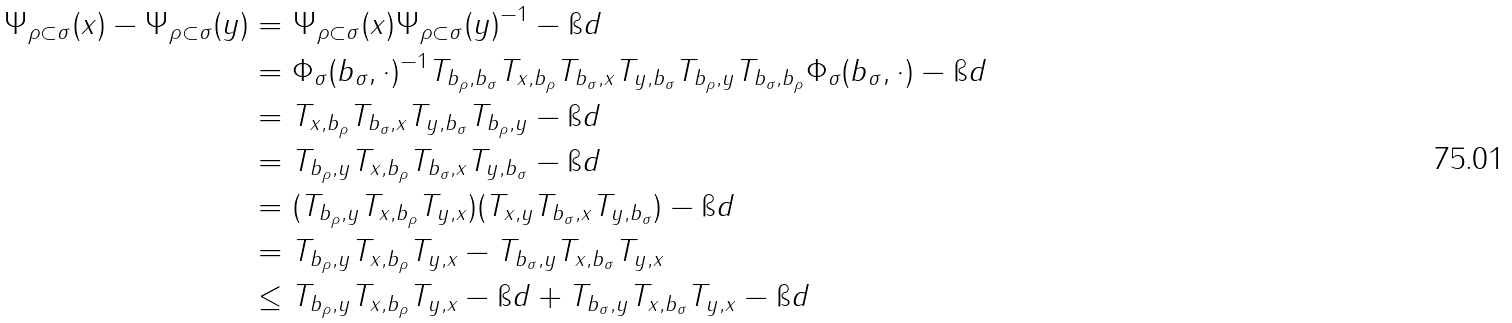<formula> <loc_0><loc_0><loc_500><loc_500>\| \Psi _ { \rho \subset \sigma } ( x ) - \Psi _ { \rho \subset \sigma } ( y ) \| & = \| \Psi _ { \rho \subset \sigma } ( x ) \Psi _ { \rho \subset \sigma } ( y ) ^ { - 1 } - \i d \| \\ & = \| \Phi _ { \sigma } ( b _ { \sigma } , \cdot ) ^ { - 1 } T _ { b _ { \rho } , b _ { \sigma } } T _ { x , b _ { \rho } } T _ { b _ { \sigma } , x } T _ { y , b _ { \sigma } } T _ { b _ { \rho } , y } T _ { b _ { \sigma } , b _ { \rho } } \Phi _ { \sigma } ( b _ { \sigma } , \cdot ) - \i d \| \\ & = \| T _ { x , b _ { \rho } } T _ { b _ { \sigma } , x } T _ { y , b _ { \sigma } } T _ { b _ { \rho } , y } - \i d \| \\ & = \| T _ { b _ { \rho } , y } T _ { x , b _ { \rho } } T _ { b _ { \sigma } , x } T _ { y , b _ { \sigma } } - \i d \| \\ & = \| ( T _ { b _ { \rho } , y } T _ { x , b _ { \rho } } T _ { y , x } ) ( T _ { x , y } T _ { b _ { \sigma } , x } T _ { y , b _ { \sigma } } ) - \i d \| \\ & = \| T _ { b _ { \rho } , y } T _ { x , b _ { \rho } } T _ { y , x } - T _ { b _ { \sigma } , y } T _ { x , b _ { \sigma } } T _ { y , x } \| \\ & \leq \| T _ { b _ { \rho } , y } T _ { x , b _ { \rho } } T _ { y , x } - \i d \| + \| T _ { b _ { \sigma } , y } T _ { x , b _ { \sigma } } T _ { y , x } - \i d \|</formula> 